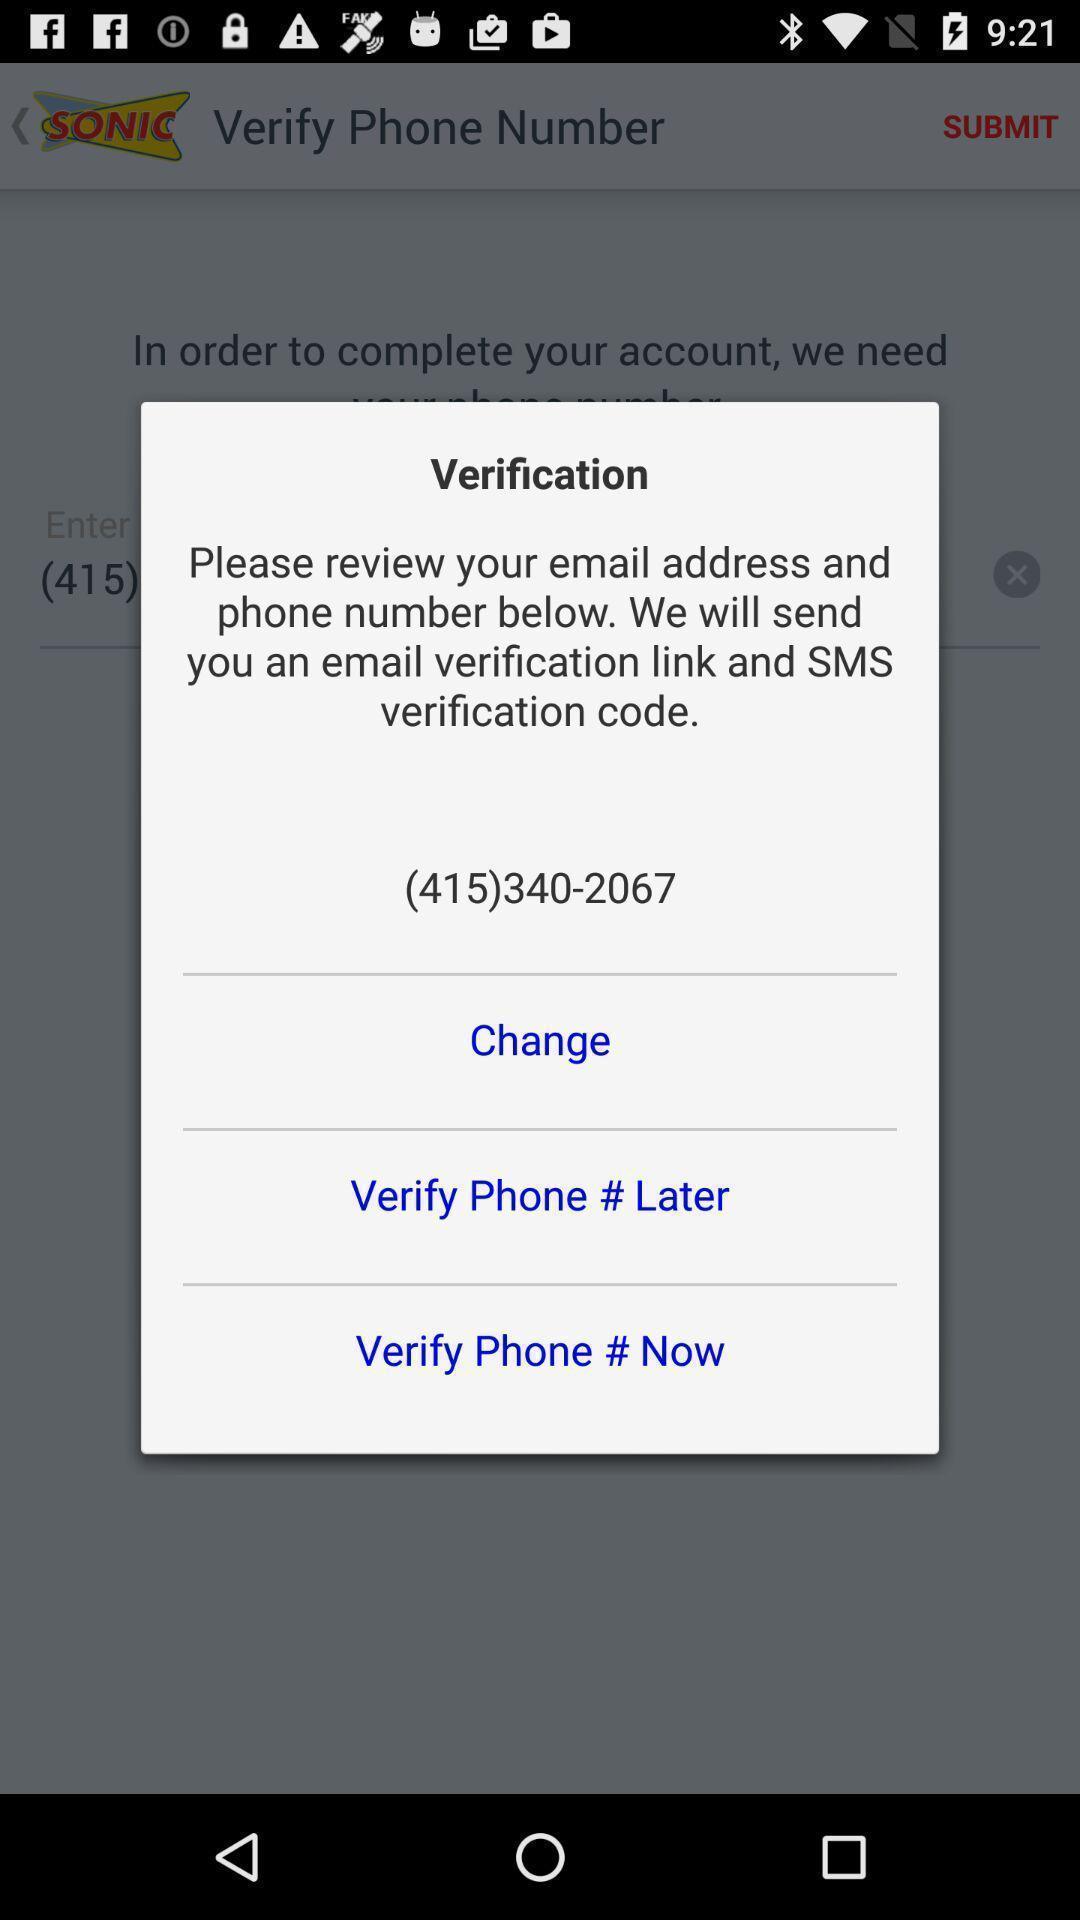Explain what's happening in this screen capture. Push up message showing verification details. 